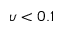<formula> <loc_0><loc_0><loc_500><loc_500>\upsilon < 0 . 1</formula> 